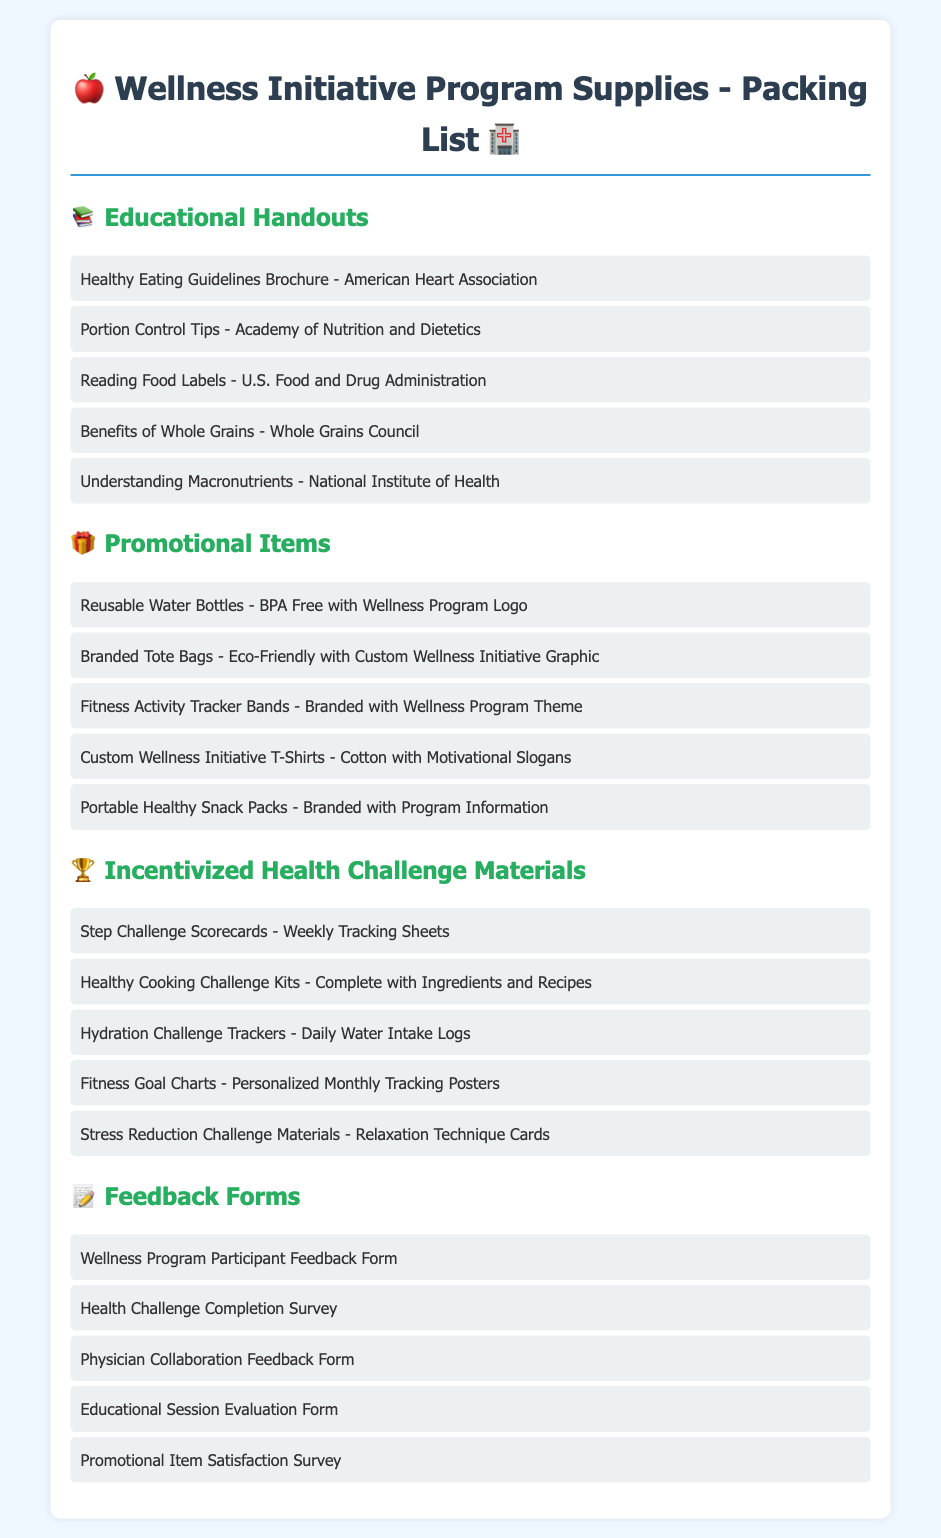What is the title of the document? The title is found at the top of the document, which describes the contents and purpose.
Answer: Wellness Initiative Program Supplies - Packing List How many categories of supplies are listed? The document contains four distinct categories of supplies organized for easy reference.
Answer: Four What is one type of educational handout included? The document lists various educational materials, specifically under the Educational Handouts category.
Answer: Healthy Eating Guidelines Brochure What type of promotional item is mentioned? The document categorizes specific promotional materials aimed at engaging participants in the wellness program.
Answer: Reusable Water Bottles What is included in the incentivized health challenge materials? The document outlines several resources aimed at motivating individuals to engage in health challenges effectively.
Answer: Step Challenge Scorecards What type of feedback form is provided? The document lists different forms for gathering participant opinions, which helps evaluate the program's effectiveness.
Answer: Wellness Program Participant Feedback Form Which organization provides the "Reading Food Labels" handout? The handout information is specified in the Educational Handouts section along with its source.
Answer: U.S. Food and Drug Administration How many feedback forms are listed in total? The document details the different feedback options available for participants and physicians to assess the program's impact.
Answer: Five 